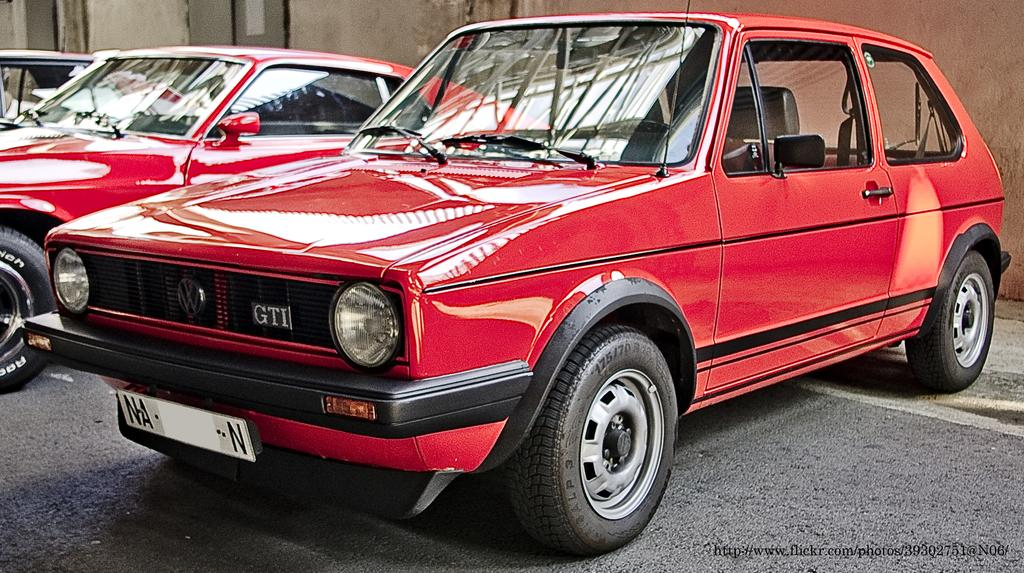<image>
Provide a brief description of the given image. red GTI with license plate that starts with NA and ends in N 